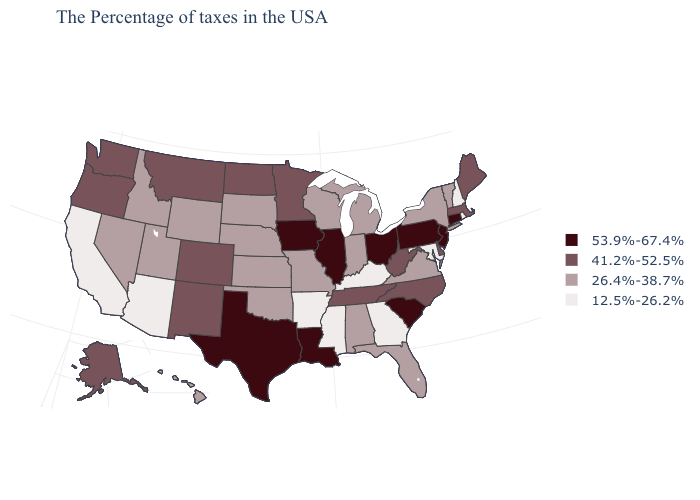What is the value of Colorado?
Write a very short answer. 41.2%-52.5%. What is the value of Maine?
Write a very short answer. 41.2%-52.5%. Name the states that have a value in the range 12.5%-26.2%?
Keep it brief. Rhode Island, New Hampshire, Maryland, Georgia, Kentucky, Mississippi, Arkansas, Arizona, California. Does Alabama have the highest value in the USA?
Answer briefly. No. Does New Hampshire have the highest value in the Northeast?
Quick response, please. No. Is the legend a continuous bar?
Give a very brief answer. No. Which states hav the highest value in the South?
Concise answer only. South Carolina, Louisiana, Texas. Name the states that have a value in the range 12.5%-26.2%?
Be succinct. Rhode Island, New Hampshire, Maryland, Georgia, Kentucky, Mississippi, Arkansas, Arizona, California. What is the value of New Mexico?
Give a very brief answer. 41.2%-52.5%. Name the states that have a value in the range 26.4%-38.7%?
Write a very short answer. Vermont, New York, Virginia, Florida, Michigan, Indiana, Alabama, Wisconsin, Missouri, Kansas, Nebraska, Oklahoma, South Dakota, Wyoming, Utah, Idaho, Nevada, Hawaii. How many symbols are there in the legend?
Quick response, please. 4. How many symbols are there in the legend?
Quick response, please. 4. Does New Mexico have the lowest value in the West?
Concise answer only. No. Does Mississippi have the lowest value in the USA?
Concise answer only. Yes. Name the states that have a value in the range 26.4%-38.7%?
Keep it brief. Vermont, New York, Virginia, Florida, Michigan, Indiana, Alabama, Wisconsin, Missouri, Kansas, Nebraska, Oklahoma, South Dakota, Wyoming, Utah, Idaho, Nevada, Hawaii. 